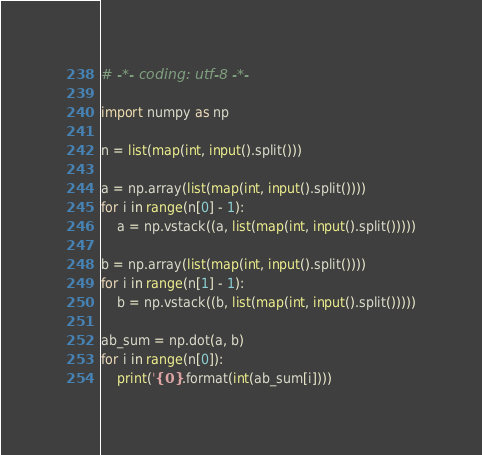Convert code to text. <code><loc_0><loc_0><loc_500><loc_500><_Python_># -*- coding: utf-8 -*-

import numpy as np

n = list(map(int, input().split()))

a = np.array(list(map(int, input().split())))
for i in range(n[0] - 1):
    a = np.vstack((a, list(map(int, input().split()))))

b = np.array(list(map(int, input().split())))
for i in range(n[1] - 1):
    b = np.vstack((b, list(map(int, input().split()))))

ab_sum = np.dot(a, b)
for i in range(n[0]):
    print('{0}'.format(int(ab_sum[i])))

</code> 